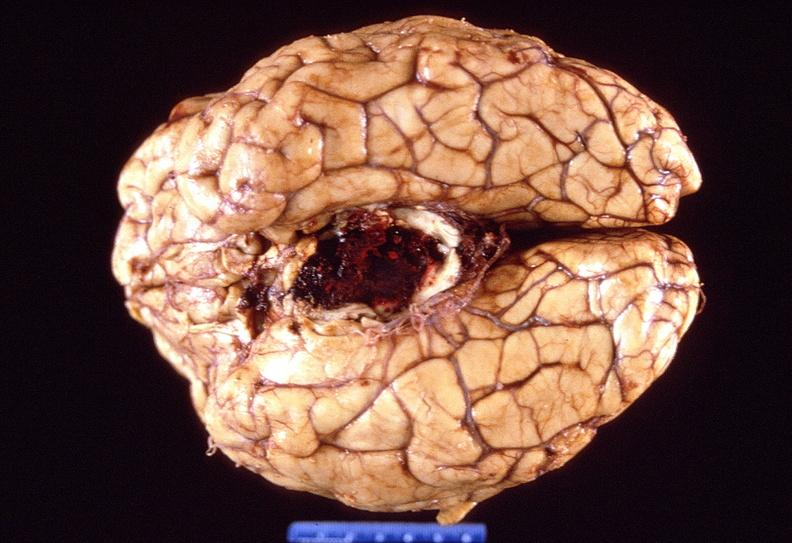does this image show brain, intracerebral hemorrhage?
Answer the question using a single word or phrase. Yes 